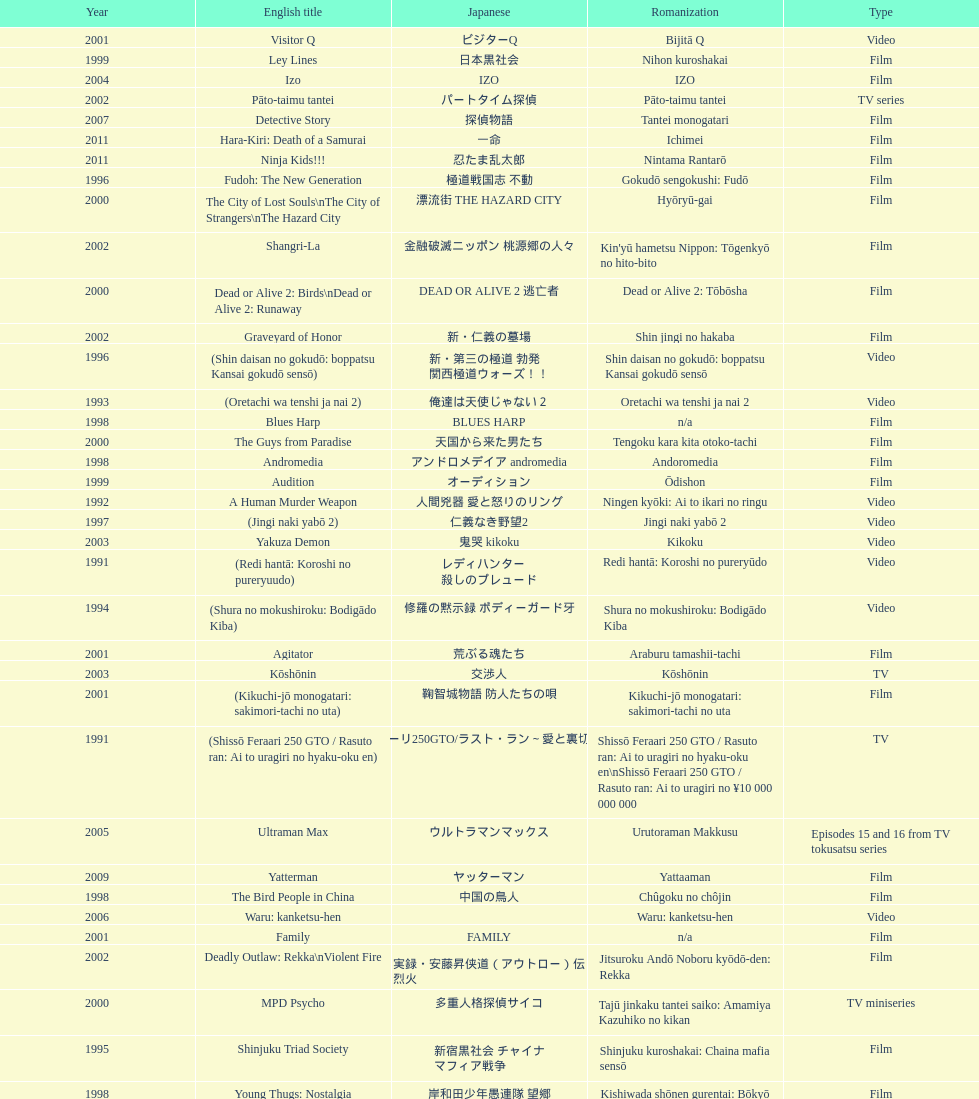Were more air on tv or video? Video. 